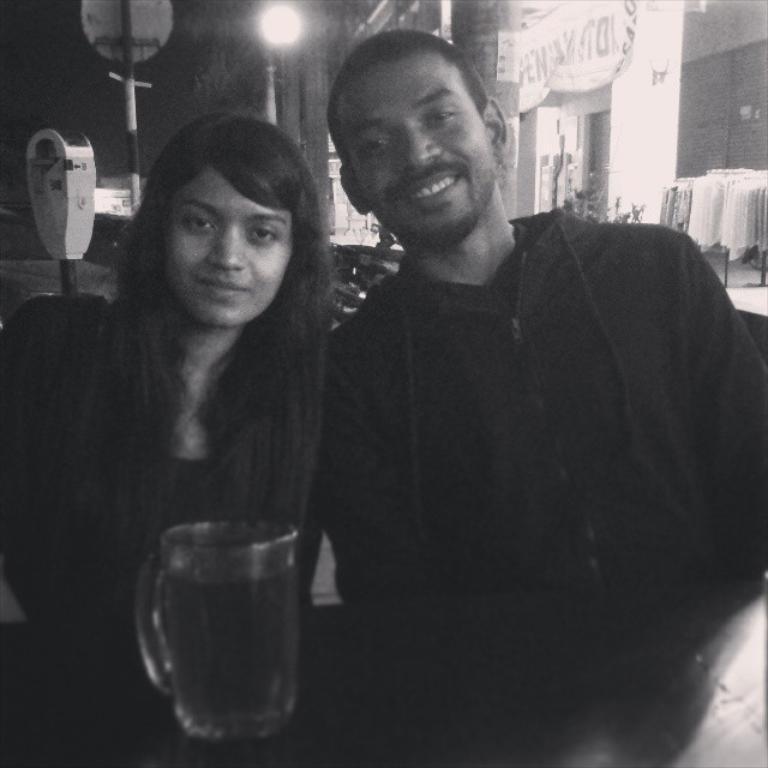How would you summarize this image in a sentence or two? This is of a black and white image. Here is the woman and man sitting and smiling. I can see a glass jug placed on the table. At background this looks like a light. Here I can see a kind of clothes hanging. This looks like a banner. These are the poles. 